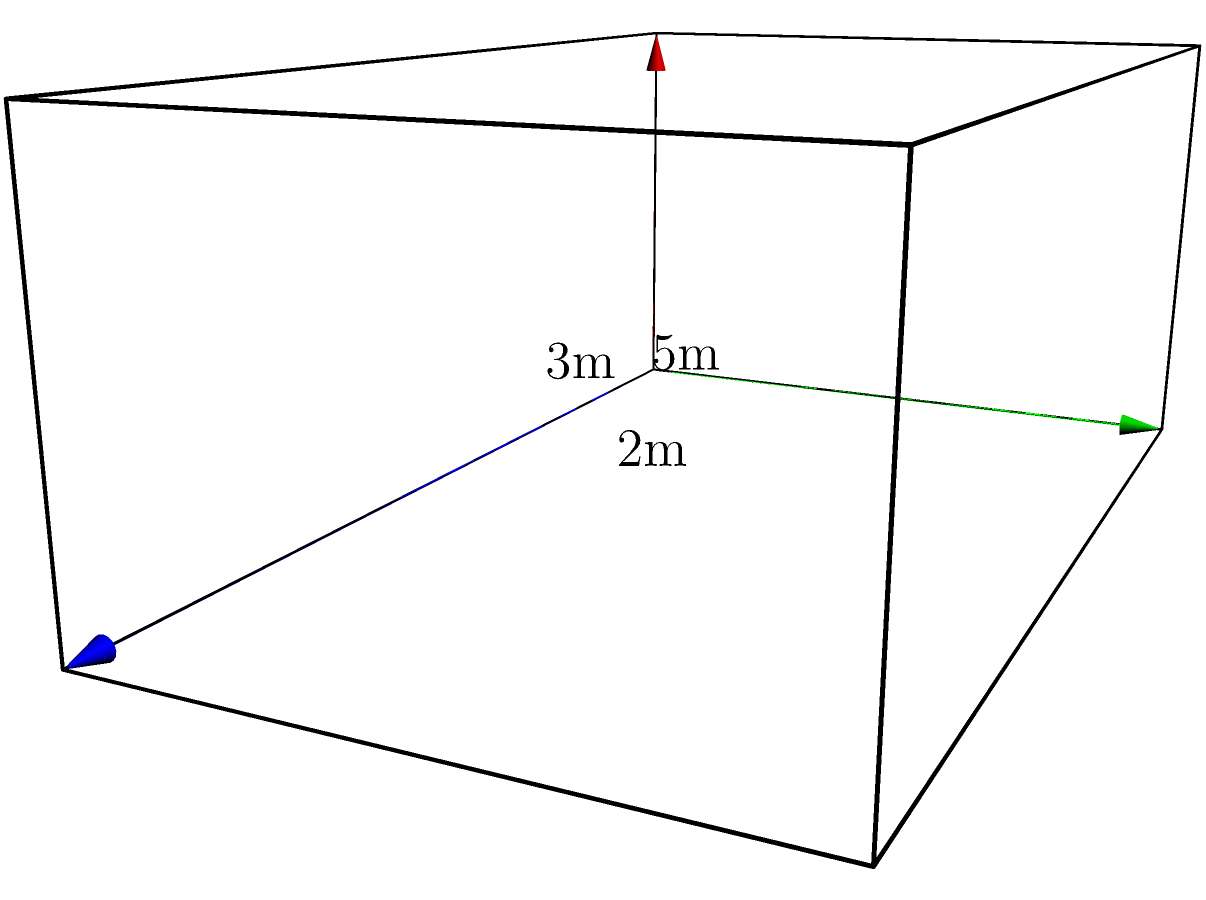A cryptocurrency mining company is designing a new mining rig enclosure modeled as a rectangular prism. The dimensions are 5 meters in length, 3 meters in width, and 2 meters in height. What is the volume of this mining rig enclosure in cubic meters? To calculate the volume of a rectangular prism, we use the formula:

$$V = l \times w \times h$$

Where:
$V$ = Volume
$l$ = Length
$w$ = Width
$h$ = Height

Given the dimensions:
$l = 5$ meters
$w = 3$ meters
$h = 2$ meters

Let's substitute these values into the formula:

$$V = 5 \times 3 \times 2$$

Now, let's perform the multiplication:

$$V = 30$$

Therefore, the volume of the mining rig enclosure is 30 cubic meters.
Answer: 30 m³ 